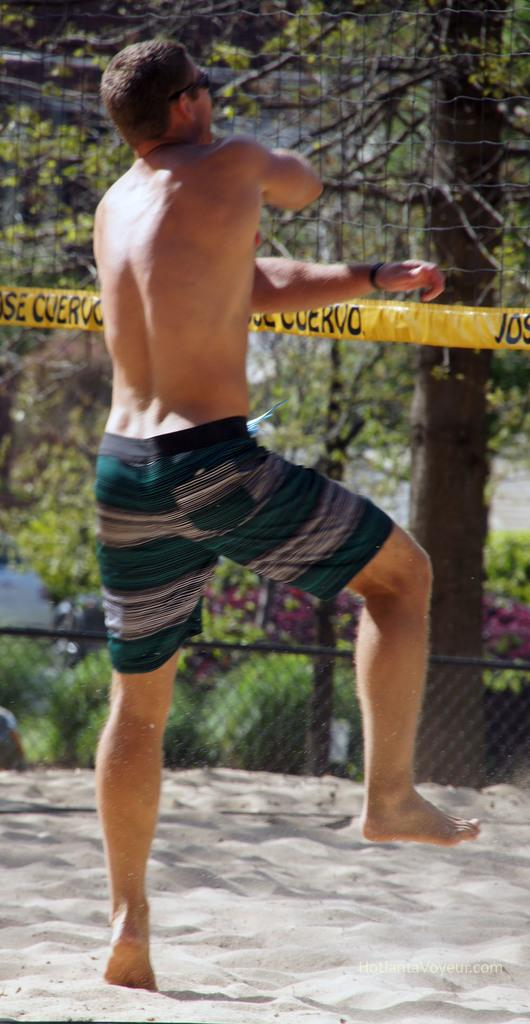Who is present in the image? There is a man in the image. What type of terrain is visible in the image? There is sand in the image. What material is present in the image? There is mesh in the image. What type of vegetation can be seen in the image? There are plants and trees in the image. Can you describe the unspecified object in the image? Unfortunately, the facts provided do not give any details about the unspecified object. What arithmetic problem is the man solving in the image? There is no indication in the image that the man is solving an arithmetic problem. Where is the pail located in the image? There is no pail present in the image. 